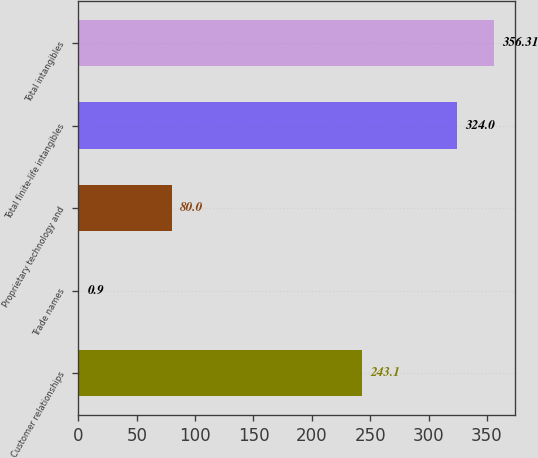<chart> <loc_0><loc_0><loc_500><loc_500><bar_chart><fcel>Customer relationships<fcel>Trade names<fcel>Proprietary technology and<fcel>Total finite-life intangibles<fcel>Total intangibles<nl><fcel>243.1<fcel>0.9<fcel>80<fcel>324<fcel>356.31<nl></chart> 